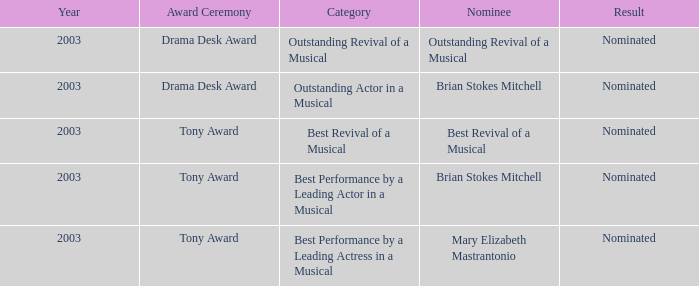What was the result for the nomination of Best Revival of a Musical? Nominated. 